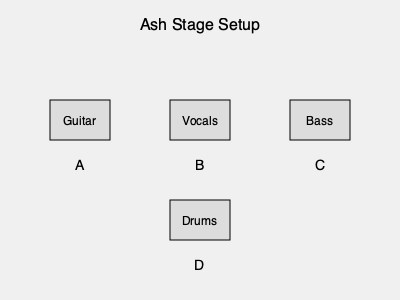Based on the stage setup diagram for Ash, match the band members to their positions: Tim Wheeler, Mark Hamilton, Rick McMurray, and Charlotte Hatherley. Which letter corresponds to Charlotte Hatherley's position? To answer this question, let's break down the information we have:

1. Ash's lineup in the '90s consisted of:
   - Tim Wheeler: Lead vocals and guitar
   - Mark Hamilton: Bass
   - Rick McMurray: Drums
   - Charlotte Hatherley: Guitar (joined in 1997)

2. Analyzing the stage setup:
   - Position A: Guitar
   - Position B: Vocals
   - Position C: Bass
   - Position D: Drums

3. Matching the positions:
   - Tim Wheeler would be at position B (Vocals) and also plays guitar
   - Mark Hamilton would be at position C (Bass)
   - Rick McMurray would be at position D (Drums)
   - Charlotte Hatherley, as the second guitarist, would be at position A (Guitar)

Therefore, Charlotte Hatherley's position in the stage setup diagram is represented by the letter A.
Answer: A 